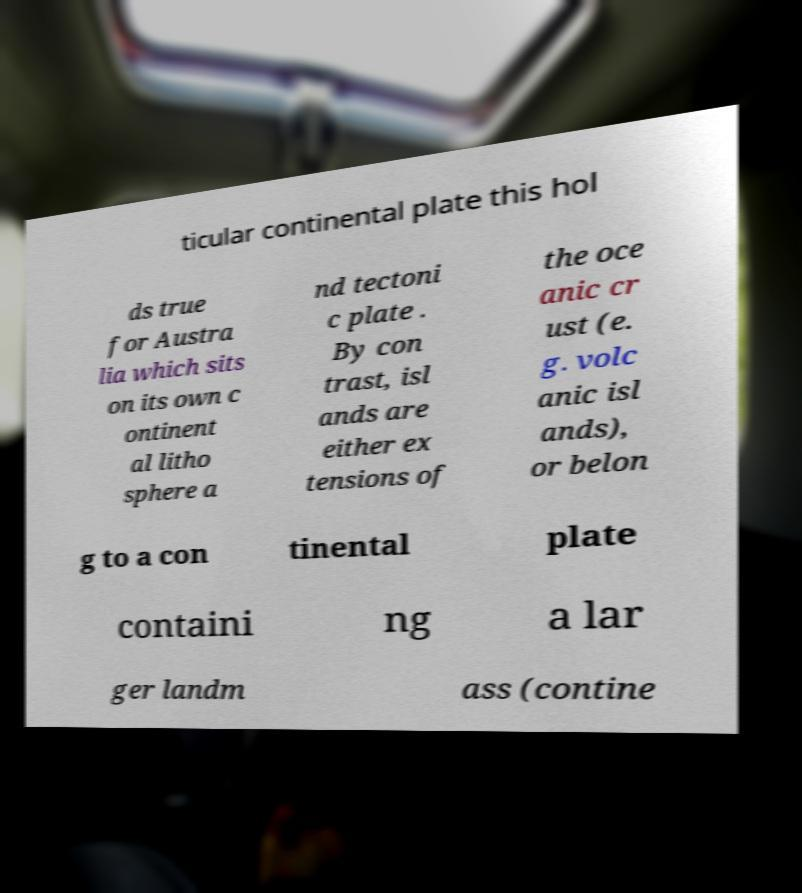Please read and relay the text visible in this image. What does it say? ticular continental plate this hol ds true for Austra lia which sits on its own c ontinent al litho sphere a nd tectoni c plate . By con trast, isl ands are either ex tensions of the oce anic cr ust (e. g. volc anic isl ands), or belon g to a con tinental plate containi ng a lar ger landm ass (contine 